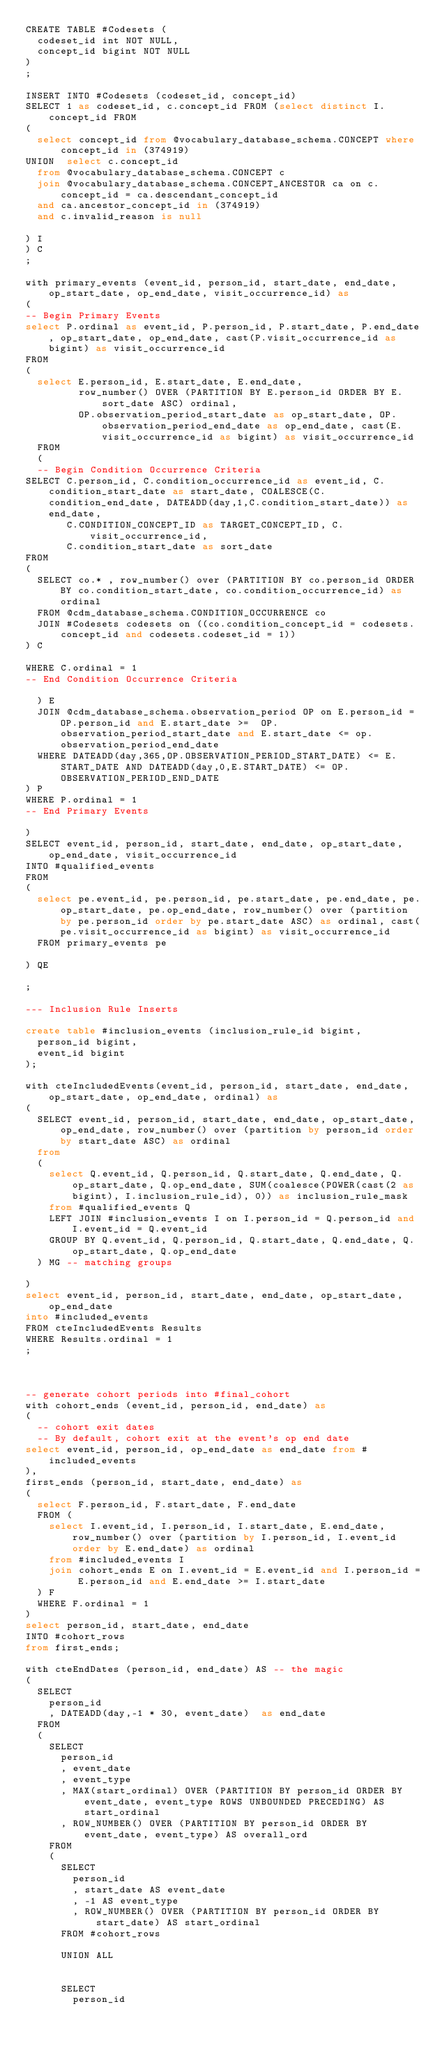Convert code to text. <code><loc_0><loc_0><loc_500><loc_500><_SQL_>CREATE TABLE #Codesets (
  codeset_id int NOT NULL,
  concept_id bigint NOT NULL
)
;

INSERT INTO #Codesets (codeset_id, concept_id)
SELECT 1 as codeset_id, c.concept_id FROM (select distinct I.concept_id FROM
( 
  select concept_id from @vocabulary_database_schema.CONCEPT where concept_id in (374919)
UNION  select c.concept_id
  from @vocabulary_database_schema.CONCEPT c
  join @vocabulary_database_schema.CONCEPT_ANCESTOR ca on c.concept_id = ca.descendant_concept_id
  and ca.ancestor_concept_id in (374919)
  and c.invalid_reason is null

) I
) C
;

with primary_events (event_id, person_id, start_date, end_date, op_start_date, op_end_date, visit_occurrence_id) as
(
-- Begin Primary Events
select P.ordinal as event_id, P.person_id, P.start_date, P.end_date, op_start_date, op_end_date, cast(P.visit_occurrence_id as bigint) as visit_occurrence_id
FROM
(
  select E.person_id, E.start_date, E.end_date,
         row_number() OVER (PARTITION BY E.person_id ORDER BY E.sort_date ASC) ordinal,
         OP.observation_period_start_date as op_start_date, OP.observation_period_end_date as op_end_date, cast(E.visit_occurrence_id as bigint) as visit_occurrence_id
  FROM 
  (
  -- Begin Condition Occurrence Criteria
SELECT C.person_id, C.condition_occurrence_id as event_id, C.condition_start_date as start_date, COALESCE(C.condition_end_date, DATEADD(day,1,C.condition_start_date)) as end_date,
       C.CONDITION_CONCEPT_ID as TARGET_CONCEPT_ID, C.visit_occurrence_id,
       C.condition_start_date as sort_date
FROM 
(
  SELECT co.* , row_number() over (PARTITION BY co.person_id ORDER BY co.condition_start_date, co.condition_occurrence_id) as ordinal
  FROM @cdm_database_schema.CONDITION_OCCURRENCE co
  JOIN #Codesets codesets on ((co.condition_concept_id = codesets.concept_id and codesets.codeset_id = 1))
) C

WHERE C.ordinal = 1
-- End Condition Occurrence Criteria

  ) E
	JOIN @cdm_database_schema.observation_period OP on E.person_id = OP.person_id and E.start_date >=  OP.observation_period_start_date and E.start_date <= op.observation_period_end_date
  WHERE DATEADD(day,365,OP.OBSERVATION_PERIOD_START_DATE) <= E.START_DATE AND DATEADD(day,0,E.START_DATE) <= OP.OBSERVATION_PERIOD_END_DATE
) P
WHERE P.ordinal = 1
-- End Primary Events

)
SELECT event_id, person_id, start_date, end_date, op_start_date, op_end_date, visit_occurrence_id
INTO #qualified_events
FROM 
(
  select pe.event_id, pe.person_id, pe.start_date, pe.end_date, pe.op_start_date, pe.op_end_date, row_number() over (partition by pe.person_id order by pe.start_date ASC) as ordinal, cast(pe.visit_occurrence_id as bigint) as visit_occurrence_id
  FROM primary_events pe
  
) QE

;

--- Inclusion Rule Inserts

create table #inclusion_events (inclusion_rule_id bigint,
	person_id bigint,
	event_id bigint
);

with cteIncludedEvents(event_id, person_id, start_date, end_date, op_start_date, op_end_date, ordinal) as
(
  SELECT event_id, person_id, start_date, end_date, op_start_date, op_end_date, row_number() over (partition by person_id order by start_date ASC) as ordinal
  from
  (
    select Q.event_id, Q.person_id, Q.start_date, Q.end_date, Q.op_start_date, Q.op_end_date, SUM(coalesce(POWER(cast(2 as bigint), I.inclusion_rule_id), 0)) as inclusion_rule_mask
    from #qualified_events Q
    LEFT JOIN #inclusion_events I on I.person_id = Q.person_id and I.event_id = Q.event_id
    GROUP BY Q.event_id, Q.person_id, Q.start_date, Q.end_date, Q.op_start_date, Q.op_end_date
  ) MG -- matching groups

)
select event_id, person_id, start_date, end_date, op_start_date, op_end_date
into #included_events
FROM cteIncludedEvents Results
WHERE Results.ordinal = 1
;



-- generate cohort periods into #final_cohort
with cohort_ends (event_id, person_id, end_date) as
(
	-- cohort exit dates
  -- By default, cohort exit at the event's op end date
select event_id, person_id, op_end_date as end_date from #included_events
),
first_ends (person_id, start_date, end_date) as
(
	select F.person_id, F.start_date, F.end_date
	FROM (
	  select I.event_id, I.person_id, I.start_date, E.end_date, row_number() over (partition by I.person_id, I.event_id order by E.end_date) as ordinal 
	  from #included_events I
	  join cohort_ends E on I.event_id = E.event_id and I.person_id = E.person_id and E.end_date >= I.start_date
	) F
	WHERE F.ordinal = 1
)
select person_id, start_date, end_date
INTO #cohort_rows
from first_ends;

with cteEndDates (person_id, end_date) AS -- the magic
(	
	SELECT
		person_id
		, DATEADD(day,-1 * 30, event_date)  as end_date
	FROM
	(
		SELECT
			person_id
			, event_date
			, event_type
			, MAX(start_ordinal) OVER (PARTITION BY person_id ORDER BY event_date, event_type ROWS UNBOUNDED PRECEDING) AS start_ordinal 
			, ROW_NUMBER() OVER (PARTITION BY person_id ORDER BY event_date, event_type) AS overall_ord
		FROM
		(
			SELECT
				person_id
				, start_date AS event_date
				, -1 AS event_type
				, ROW_NUMBER() OVER (PARTITION BY person_id ORDER BY start_date) AS start_ordinal
			FROM #cohort_rows
		
			UNION ALL
		

			SELECT
				person_id</code> 